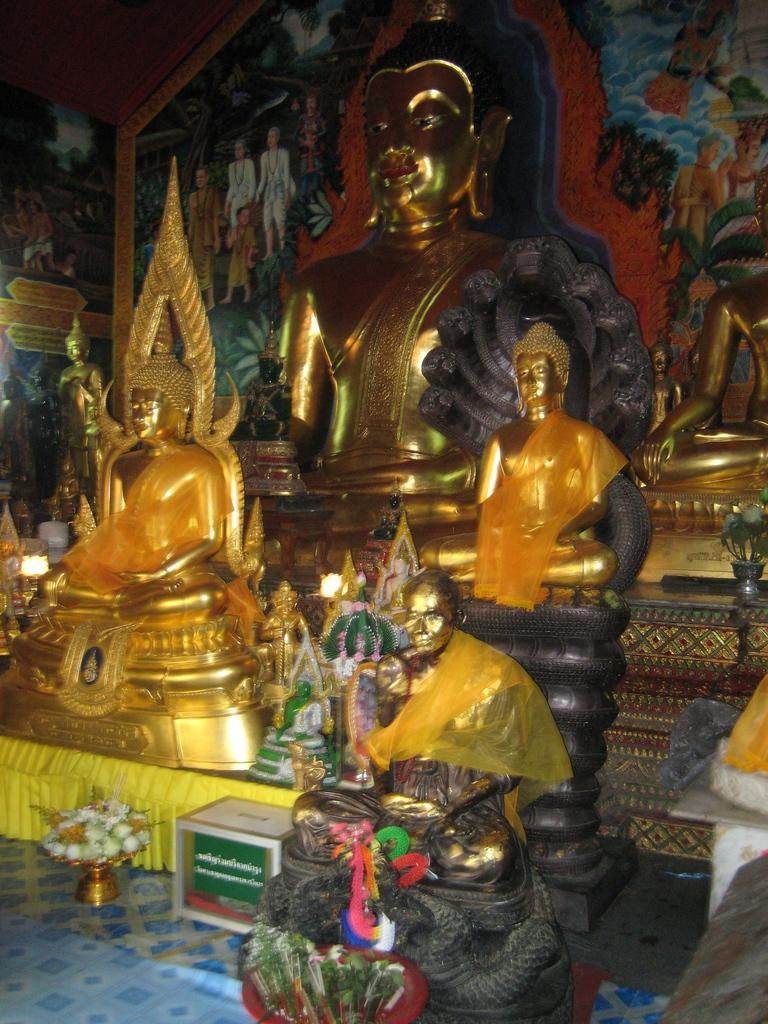What type of objects are present in the image? There are idols, a basket with flowers, a box, and other objects in the image. Can you describe the contents of the basket? The basket contains flowers. What is the location of the box in the image? The box is in the image, but its exact position cannot be determined from the provided facts. What can be seen on the walls in the background of the image? There are paintings on the walls in the background of the image. What is visible at the bottom of the image? The floor is visible at the bottom of the image. What type of secretary can be seen working in the image? There is no secretary present in the image. What is the angle of the kitty's tail in the image? There is no kitty present in the image, so its tail angle cannot be determined. 